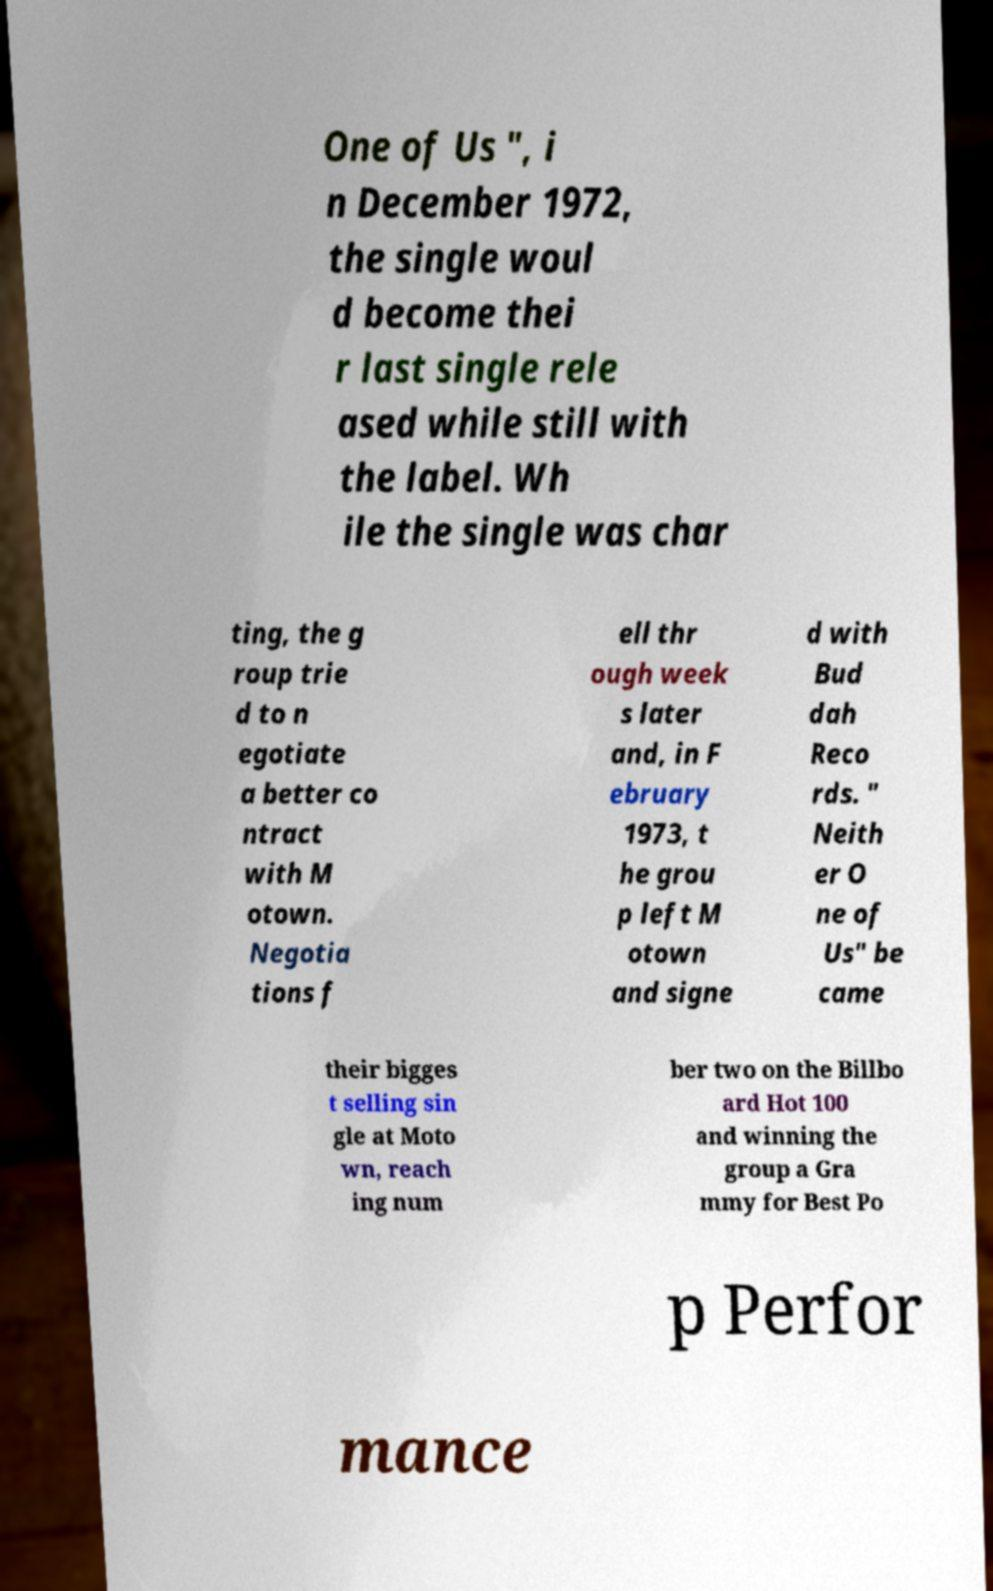Please read and relay the text visible in this image. What does it say? One of Us ", i n December 1972, the single woul d become thei r last single rele ased while still with the label. Wh ile the single was char ting, the g roup trie d to n egotiate a better co ntract with M otown. Negotia tions f ell thr ough week s later and, in F ebruary 1973, t he grou p left M otown and signe d with Bud dah Reco rds. " Neith er O ne of Us" be came their bigges t selling sin gle at Moto wn, reach ing num ber two on the Billbo ard Hot 100 and winning the group a Gra mmy for Best Po p Perfor mance 